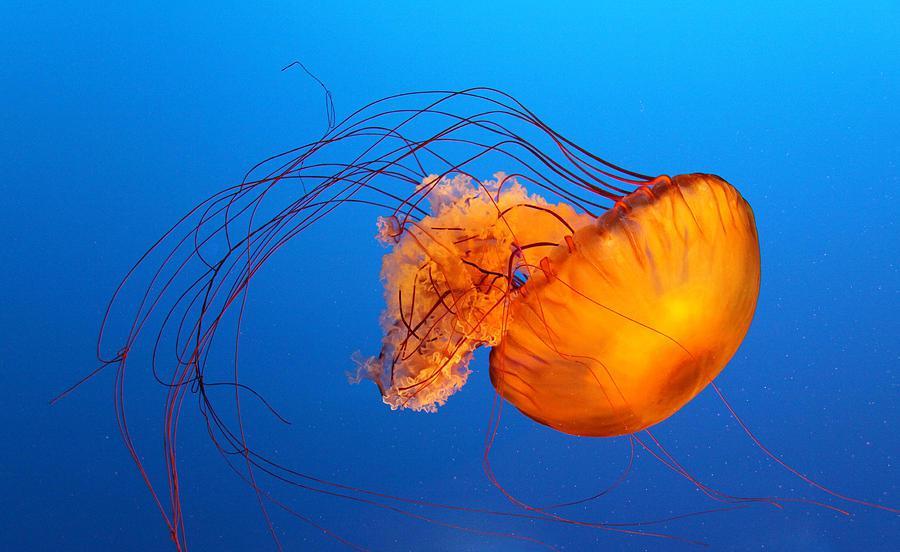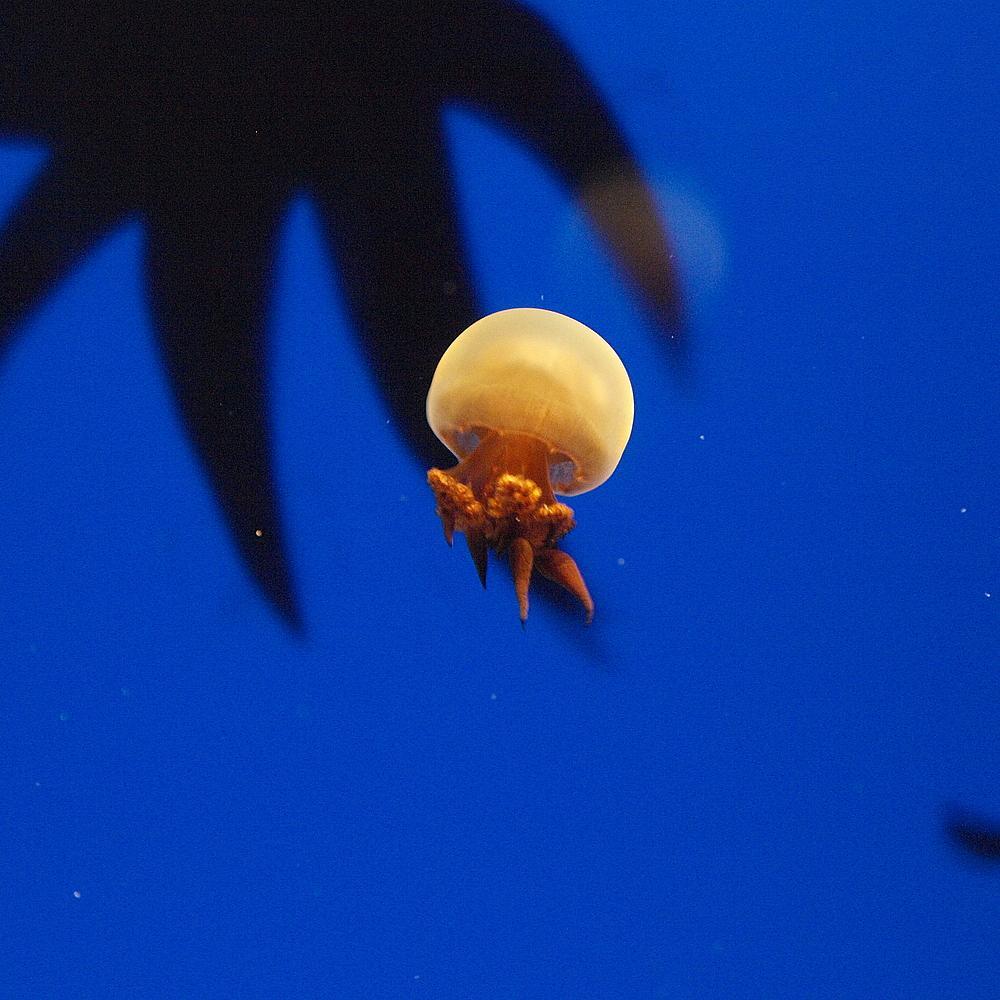The first image is the image on the left, the second image is the image on the right. Examine the images to the left and right. Is the description "long thin tendrils extend from an orange jellyfish in one of the images." accurate? Answer yes or no. Yes. 